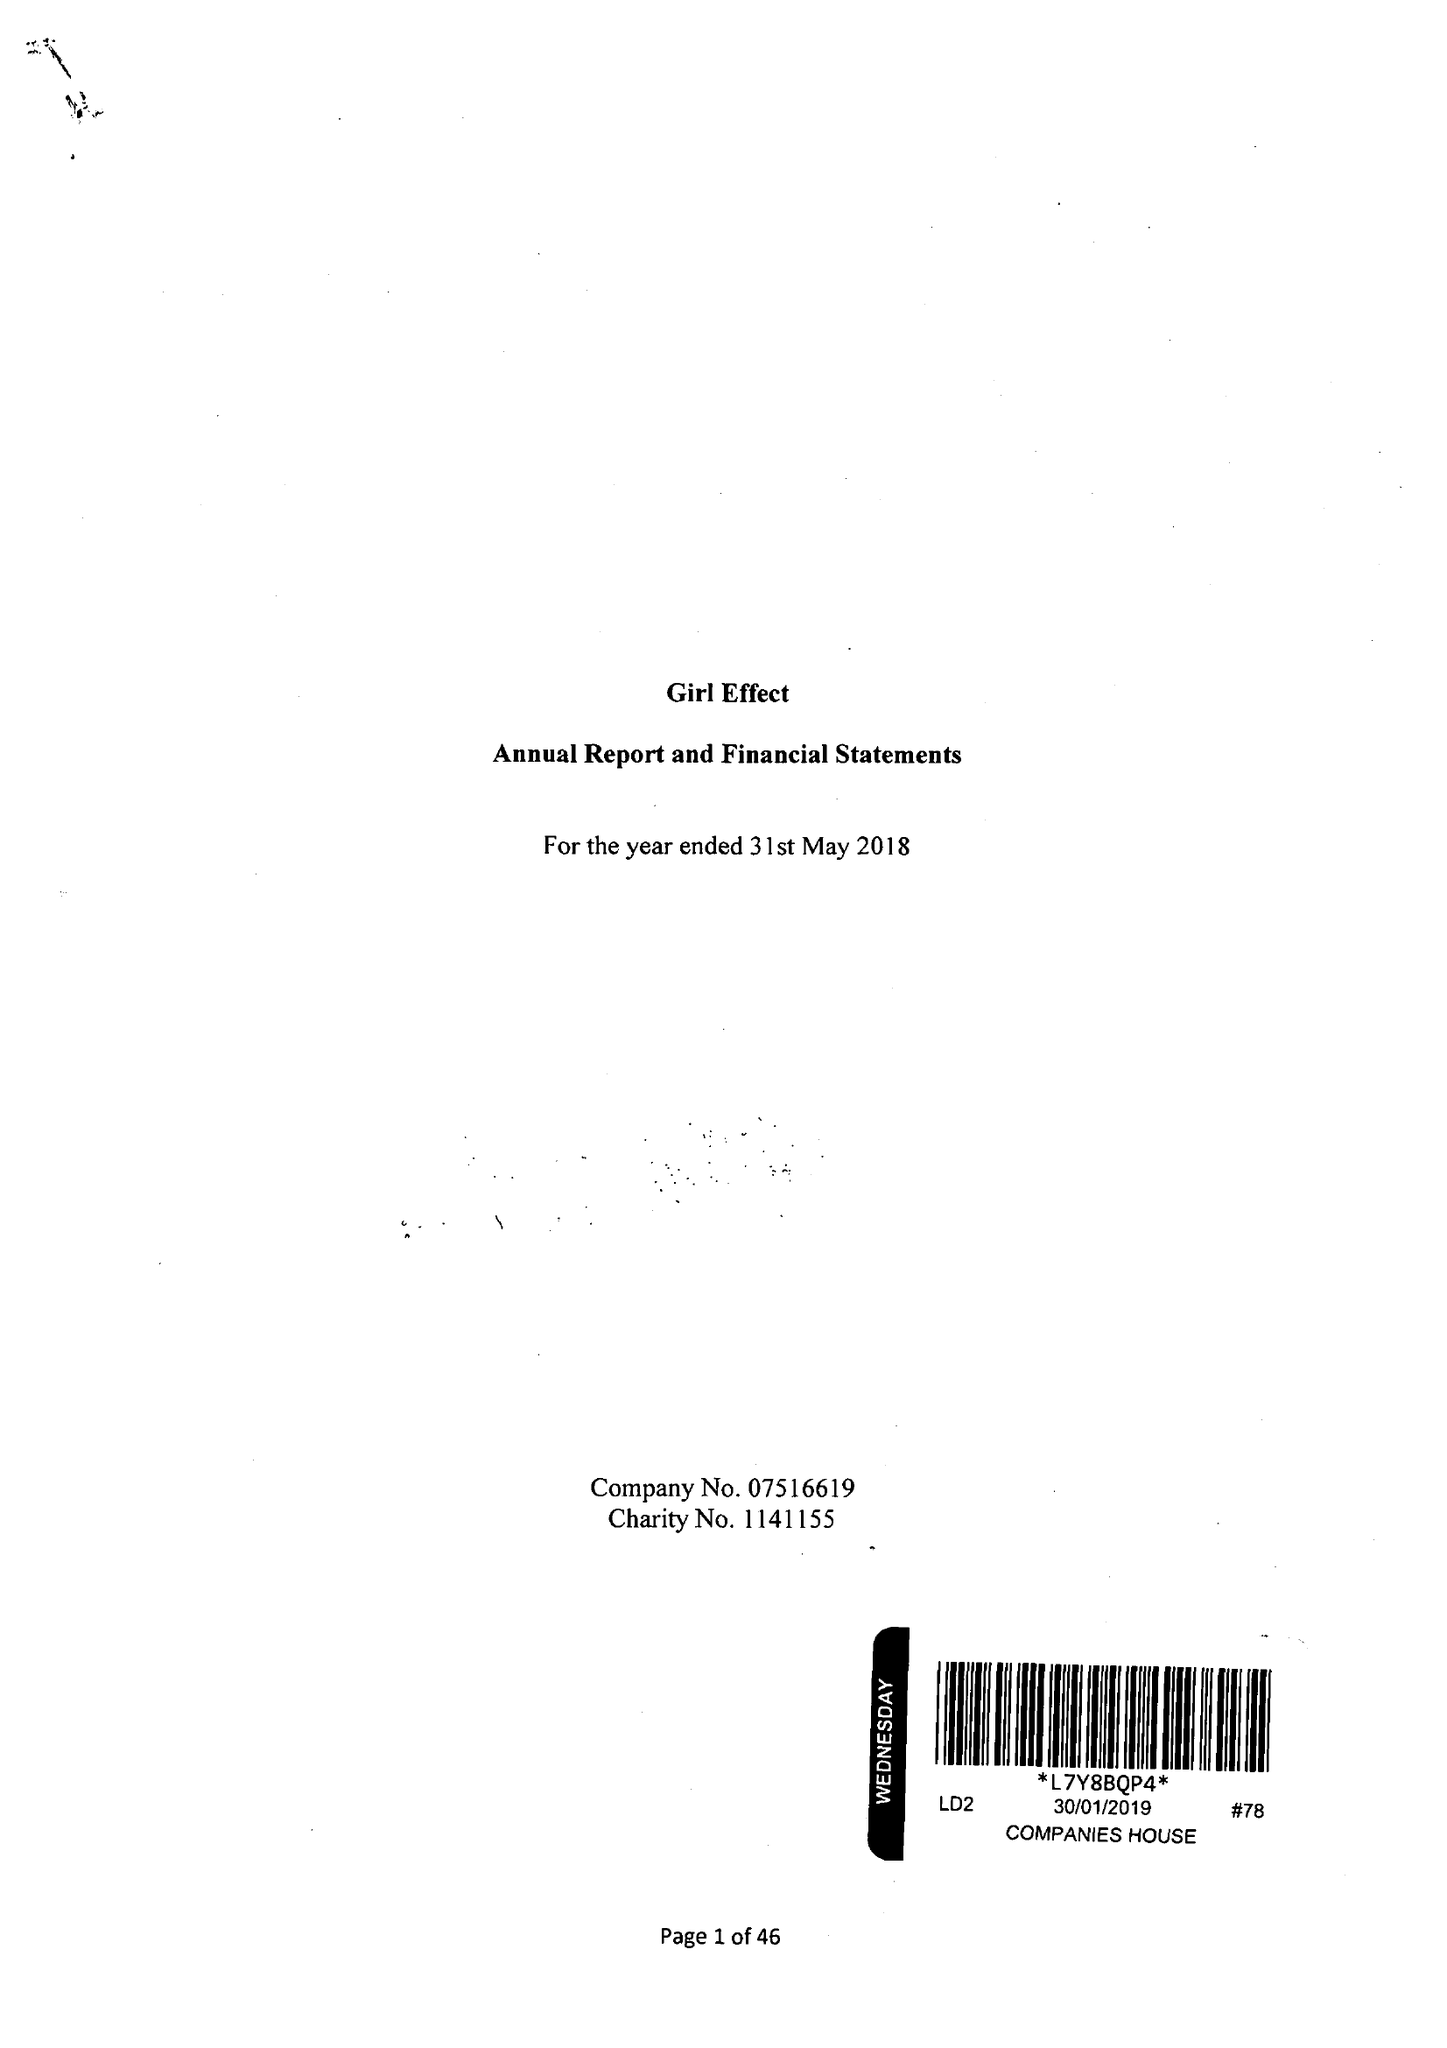What is the value for the report_date?
Answer the question using a single word or phrase. 2018-05-31 